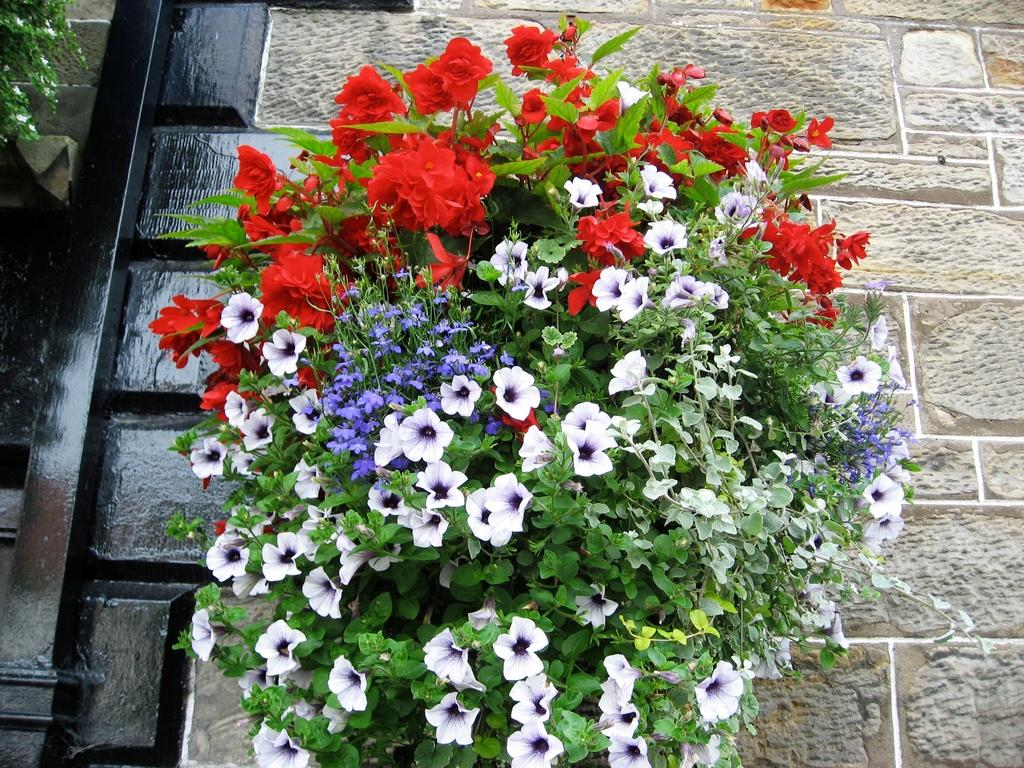What is the main subject of the image? The main subject of the image is a flower bouquet. How is the flower bouquet positioned in the image? The flower bouquet is attached to the wall. What colors of flowers are present in the bouquet? The bouquet contains white, blue, and red flowers. What is the value of the cloud in the image? There is no cloud present in the image, so it is not possible to determine its value. 